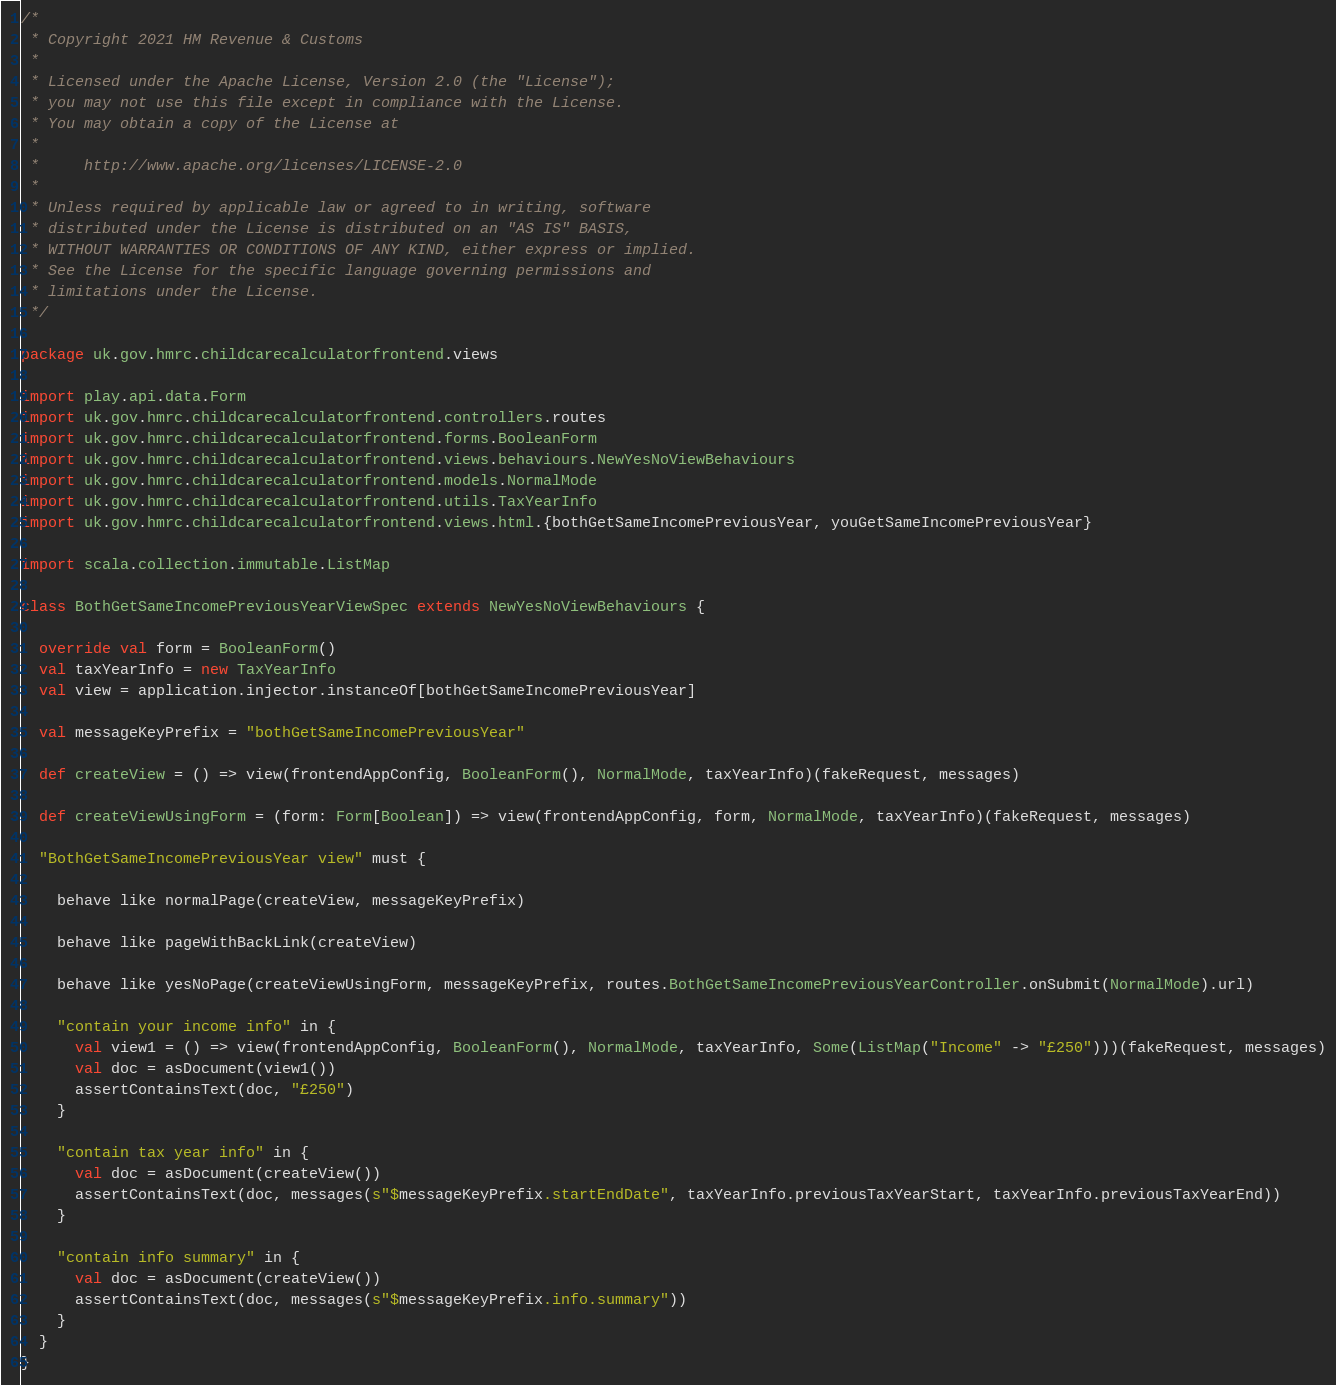Convert code to text. <code><loc_0><loc_0><loc_500><loc_500><_Scala_>/*
 * Copyright 2021 HM Revenue & Customs
 *
 * Licensed under the Apache License, Version 2.0 (the "License");
 * you may not use this file except in compliance with the License.
 * You may obtain a copy of the License at
 *
 *     http://www.apache.org/licenses/LICENSE-2.0
 *
 * Unless required by applicable law or agreed to in writing, software
 * distributed under the License is distributed on an "AS IS" BASIS,
 * WITHOUT WARRANTIES OR CONDITIONS OF ANY KIND, either express or implied.
 * See the License for the specific language governing permissions and
 * limitations under the License.
 */

package uk.gov.hmrc.childcarecalculatorfrontend.views

import play.api.data.Form
import uk.gov.hmrc.childcarecalculatorfrontend.controllers.routes
import uk.gov.hmrc.childcarecalculatorfrontend.forms.BooleanForm
import uk.gov.hmrc.childcarecalculatorfrontend.views.behaviours.NewYesNoViewBehaviours
import uk.gov.hmrc.childcarecalculatorfrontend.models.NormalMode
import uk.gov.hmrc.childcarecalculatorfrontend.utils.TaxYearInfo
import uk.gov.hmrc.childcarecalculatorfrontend.views.html.{bothGetSameIncomePreviousYear, youGetSameIncomePreviousYear}

import scala.collection.immutable.ListMap

class BothGetSameIncomePreviousYearViewSpec extends NewYesNoViewBehaviours {

  override val form = BooleanForm()
  val taxYearInfo = new TaxYearInfo
  val view = application.injector.instanceOf[bothGetSameIncomePreviousYear]

  val messageKeyPrefix = "bothGetSameIncomePreviousYear"

  def createView = () => view(frontendAppConfig, BooleanForm(), NormalMode, taxYearInfo)(fakeRequest, messages)

  def createViewUsingForm = (form: Form[Boolean]) => view(frontendAppConfig, form, NormalMode, taxYearInfo)(fakeRequest, messages)

  "BothGetSameIncomePreviousYear view" must {

    behave like normalPage(createView, messageKeyPrefix)

    behave like pageWithBackLink(createView)

    behave like yesNoPage(createViewUsingForm, messageKeyPrefix, routes.BothGetSameIncomePreviousYearController.onSubmit(NormalMode).url)

    "contain your income info" in {
      val view1 = () => view(frontendAppConfig, BooleanForm(), NormalMode, taxYearInfo, Some(ListMap("Income" -> "£250")))(fakeRequest, messages)
      val doc = asDocument(view1())
      assertContainsText(doc, "£250")
    }

    "contain tax year info" in {
      val doc = asDocument(createView())
      assertContainsText(doc, messages(s"$messageKeyPrefix.startEndDate", taxYearInfo.previousTaxYearStart, taxYearInfo.previousTaxYearEnd))
    }

    "contain info summary" in {
      val doc = asDocument(createView())
      assertContainsText(doc, messages(s"$messageKeyPrefix.info.summary"))
    }
  }
}
</code> 